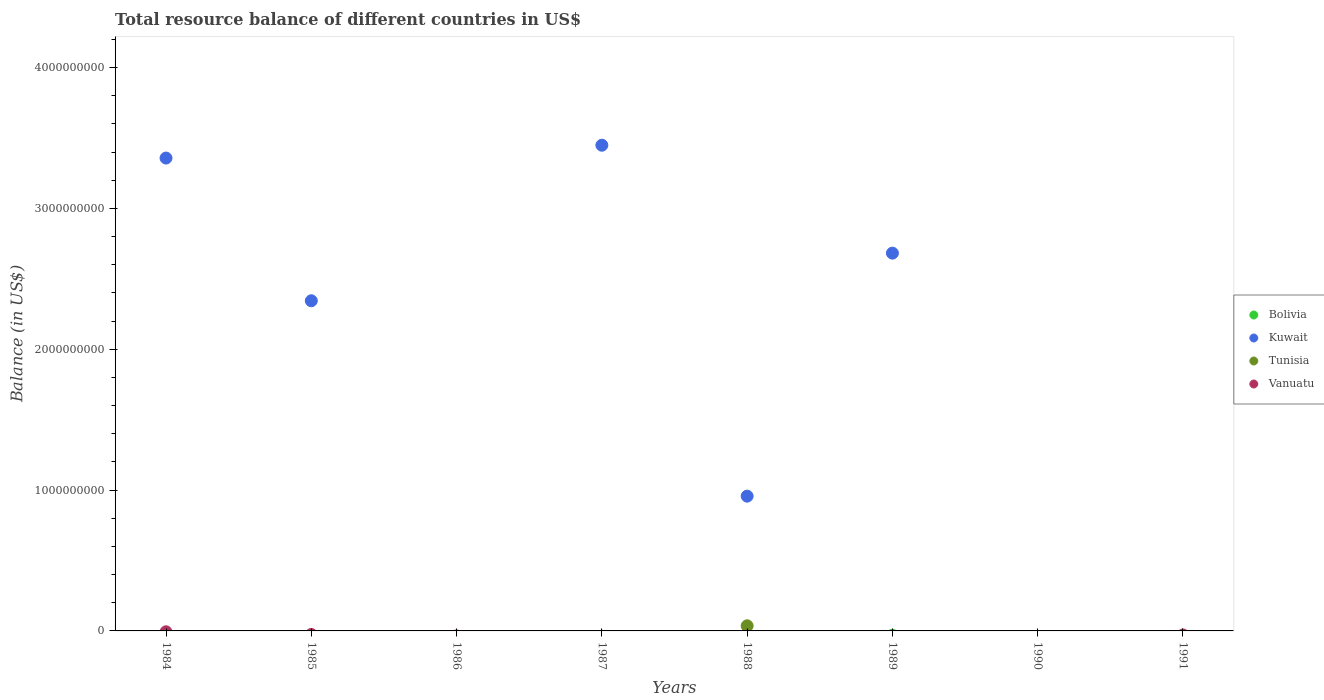How many different coloured dotlines are there?
Your answer should be very brief. 2. Across all years, what is the maximum total resource balance in Tunisia?
Offer a terse response. 3.64e+07. Across all years, what is the minimum total resource balance in Kuwait?
Ensure brevity in your answer.  0. In which year was the total resource balance in Tunisia maximum?
Provide a succinct answer. 1988. What is the total total resource balance in Kuwait in the graph?
Offer a terse response. 1.28e+1. What is the difference between the total resource balance in Bolivia in 1984 and the total resource balance in Kuwait in 1988?
Keep it short and to the point. -9.57e+08. In the year 1988, what is the difference between the total resource balance in Tunisia and total resource balance in Kuwait?
Keep it short and to the point. -9.21e+08. In how many years, is the total resource balance in Tunisia greater than 200000000 US$?
Keep it short and to the point. 0. What is the difference between the highest and the second highest total resource balance in Kuwait?
Offer a terse response. 9.12e+07. What is the difference between the highest and the lowest total resource balance in Tunisia?
Keep it short and to the point. 3.64e+07. In how many years, is the total resource balance in Kuwait greater than the average total resource balance in Kuwait taken over all years?
Your response must be concise. 4. Is it the case that in every year, the sum of the total resource balance in Tunisia and total resource balance in Kuwait  is greater than the total resource balance in Vanuatu?
Offer a terse response. No. Does the total resource balance in Vanuatu monotonically increase over the years?
Provide a short and direct response. No. Is the total resource balance in Tunisia strictly greater than the total resource balance in Vanuatu over the years?
Your answer should be compact. No. Is the total resource balance in Kuwait strictly less than the total resource balance in Bolivia over the years?
Your response must be concise. No. How many years are there in the graph?
Make the answer very short. 8. What is the difference between two consecutive major ticks on the Y-axis?
Make the answer very short. 1.00e+09. Are the values on the major ticks of Y-axis written in scientific E-notation?
Give a very brief answer. No. How many legend labels are there?
Give a very brief answer. 4. What is the title of the graph?
Provide a succinct answer. Total resource balance of different countries in US$. What is the label or title of the X-axis?
Give a very brief answer. Years. What is the label or title of the Y-axis?
Make the answer very short. Balance (in US$). What is the Balance (in US$) in Bolivia in 1984?
Provide a succinct answer. 0. What is the Balance (in US$) of Kuwait in 1984?
Your answer should be very brief. 3.36e+09. What is the Balance (in US$) of Tunisia in 1984?
Offer a terse response. 0. What is the Balance (in US$) of Vanuatu in 1984?
Offer a very short reply. 0. What is the Balance (in US$) of Kuwait in 1985?
Provide a succinct answer. 2.34e+09. What is the Balance (in US$) in Bolivia in 1986?
Keep it short and to the point. 0. What is the Balance (in US$) of Kuwait in 1986?
Make the answer very short. 0. What is the Balance (in US$) of Bolivia in 1987?
Ensure brevity in your answer.  0. What is the Balance (in US$) of Kuwait in 1987?
Your response must be concise. 3.45e+09. What is the Balance (in US$) of Tunisia in 1987?
Ensure brevity in your answer.  0. What is the Balance (in US$) of Kuwait in 1988?
Offer a terse response. 9.57e+08. What is the Balance (in US$) in Tunisia in 1988?
Provide a short and direct response. 3.64e+07. What is the Balance (in US$) in Kuwait in 1989?
Give a very brief answer. 2.68e+09. What is the Balance (in US$) in Tunisia in 1990?
Your answer should be compact. 0. What is the Balance (in US$) of Bolivia in 1991?
Ensure brevity in your answer.  0. What is the Balance (in US$) in Kuwait in 1991?
Provide a succinct answer. 0. What is the Balance (in US$) of Vanuatu in 1991?
Your answer should be compact. 0. Across all years, what is the maximum Balance (in US$) in Kuwait?
Your response must be concise. 3.45e+09. Across all years, what is the maximum Balance (in US$) in Tunisia?
Keep it short and to the point. 3.64e+07. Across all years, what is the minimum Balance (in US$) of Tunisia?
Your response must be concise. 0. What is the total Balance (in US$) of Bolivia in the graph?
Provide a succinct answer. 0. What is the total Balance (in US$) in Kuwait in the graph?
Give a very brief answer. 1.28e+1. What is the total Balance (in US$) in Tunisia in the graph?
Your response must be concise. 3.64e+07. What is the difference between the Balance (in US$) of Kuwait in 1984 and that in 1985?
Keep it short and to the point. 1.01e+09. What is the difference between the Balance (in US$) in Kuwait in 1984 and that in 1987?
Your answer should be very brief. -9.12e+07. What is the difference between the Balance (in US$) in Kuwait in 1984 and that in 1988?
Your answer should be very brief. 2.40e+09. What is the difference between the Balance (in US$) of Kuwait in 1984 and that in 1989?
Your answer should be compact. 6.75e+08. What is the difference between the Balance (in US$) in Kuwait in 1985 and that in 1987?
Your answer should be compact. -1.10e+09. What is the difference between the Balance (in US$) in Kuwait in 1985 and that in 1988?
Make the answer very short. 1.39e+09. What is the difference between the Balance (in US$) of Kuwait in 1985 and that in 1989?
Your answer should be very brief. -3.38e+08. What is the difference between the Balance (in US$) in Kuwait in 1987 and that in 1988?
Offer a terse response. 2.49e+09. What is the difference between the Balance (in US$) in Kuwait in 1987 and that in 1989?
Offer a terse response. 7.66e+08. What is the difference between the Balance (in US$) in Kuwait in 1988 and that in 1989?
Offer a very short reply. -1.73e+09. What is the difference between the Balance (in US$) of Kuwait in 1984 and the Balance (in US$) of Tunisia in 1988?
Your answer should be very brief. 3.32e+09. What is the difference between the Balance (in US$) in Kuwait in 1985 and the Balance (in US$) in Tunisia in 1988?
Ensure brevity in your answer.  2.31e+09. What is the difference between the Balance (in US$) in Kuwait in 1987 and the Balance (in US$) in Tunisia in 1988?
Offer a terse response. 3.41e+09. What is the average Balance (in US$) of Kuwait per year?
Offer a terse response. 1.60e+09. What is the average Balance (in US$) in Tunisia per year?
Offer a terse response. 4.55e+06. In the year 1988, what is the difference between the Balance (in US$) in Kuwait and Balance (in US$) in Tunisia?
Your answer should be compact. 9.21e+08. What is the ratio of the Balance (in US$) of Kuwait in 1984 to that in 1985?
Provide a succinct answer. 1.43. What is the ratio of the Balance (in US$) of Kuwait in 1984 to that in 1987?
Give a very brief answer. 0.97. What is the ratio of the Balance (in US$) of Kuwait in 1984 to that in 1988?
Keep it short and to the point. 3.51. What is the ratio of the Balance (in US$) in Kuwait in 1984 to that in 1989?
Offer a terse response. 1.25. What is the ratio of the Balance (in US$) of Kuwait in 1985 to that in 1987?
Keep it short and to the point. 0.68. What is the ratio of the Balance (in US$) of Kuwait in 1985 to that in 1988?
Your answer should be very brief. 2.45. What is the ratio of the Balance (in US$) of Kuwait in 1985 to that in 1989?
Make the answer very short. 0.87. What is the ratio of the Balance (in US$) of Kuwait in 1987 to that in 1988?
Your response must be concise. 3.6. What is the ratio of the Balance (in US$) of Kuwait in 1987 to that in 1989?
Offer a terse response. 1.29. What is the ratio of the Balance (in US$) in Kuwait in 1988 to that in 1989?
Keep it short and to the point. 0.36. What is the difference between the highest and the second highest Balance (in US$) of Kuwait?
Give a very brief answer. 9.12e+07. What is the difference between the highest and the lowest Balance (in US$) of Kuwait?
Give a very brief answer. 3.45e+09. What is the difference between the highest and the lowest Balance (in US$) of Tunisia?
Offer a terse response. 3.64e+07. 